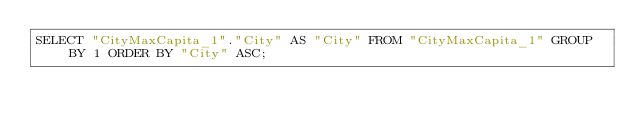Convert code to text. <code><loc_0><loc_0><loc_500><loc_500><_SQL_>SELECT "CityMaxCapita_1"."City" AS "City" FROM "CityMaxCapita_1" GROUP BY 1 ORDER BY "City" ASC;
</code> 